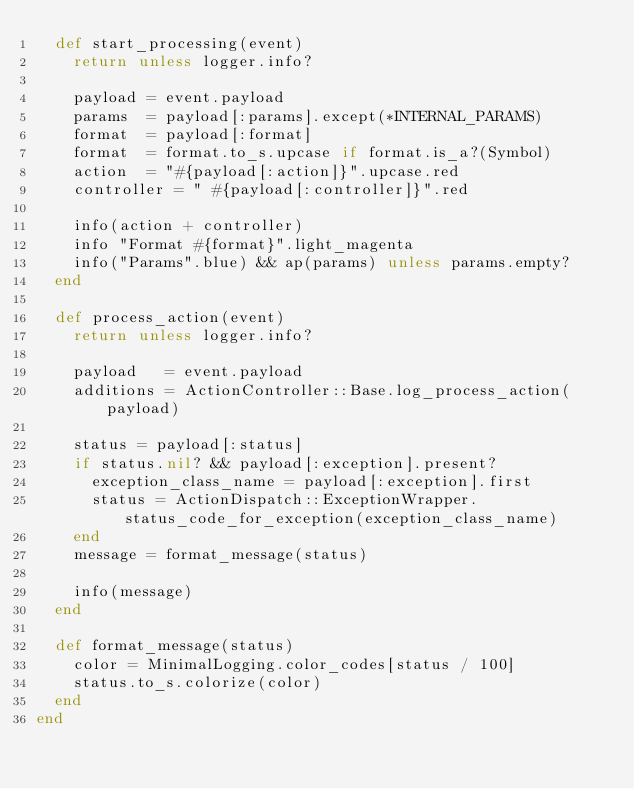Convert code to text. <code><loc_0><loc_0><loc_500><loc_500><_Ruby_>  def start_processing(event)
    return unless logger.info?

    payload = event.payload
    params  = payload[:params].except(*INTERNAL_PARAMS)
    format  = payload[:format]
    format  = format.to_s.upcase if format.is_a?(Symbol)
    action  = "#{payload[:action]}".upcase.red
    controller = " #{payload[:controller]}".red

    info(action + controller)
    info "Format #{format}".light_magenta
    info("Params".blue) && ap(params) unless params.empty?
  end

  def process_action(event)
    return unless logger.info?

    payload   = event.payload
    additions = ActionController::Base.log_process_action(payload)

    status = payload[:status]
    if status.nil? && payload[:exception].present?
      exception_class_name = payload[:exception].first
      status = ActionDispatch::ExceptionWrapper.status_code_for_exception(exception_class_name)
    end
    message = format_message(status)

    info(message)
  end

  def format_message(status)
    color = MinimalLogging.color_codes[status / 100]
    status.to_s.colorize(color)
  end
end
</code> 